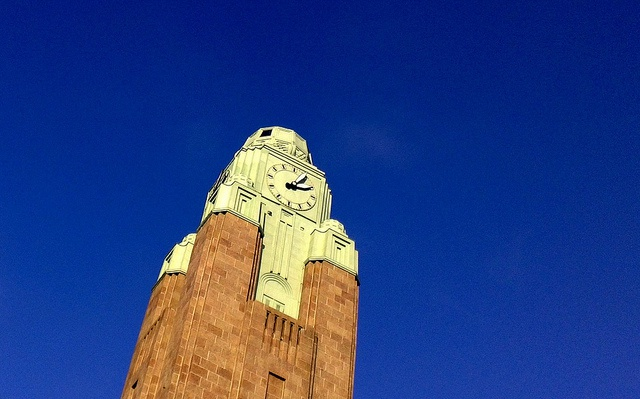Describe the objects in this image and their specific colors. I can see a clock in navy, khaki, beige, black, and tan tones in this image. 